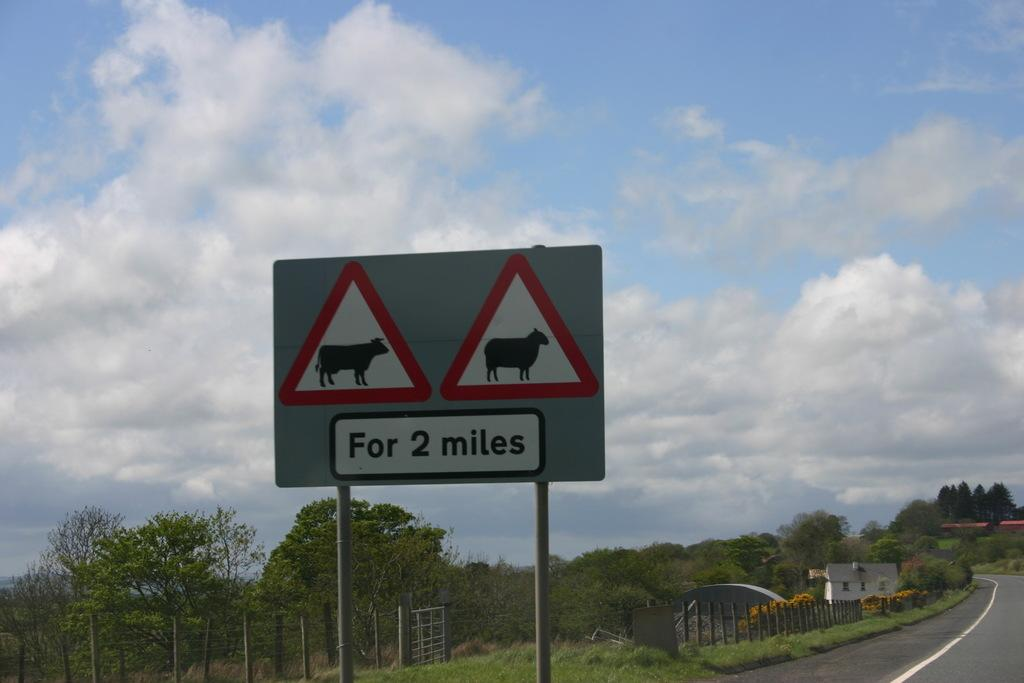<image>
Give a short and clear explanation of the subsequent image. A sign warning drivers about farm animals for the next 2 miles is visible along a road. 